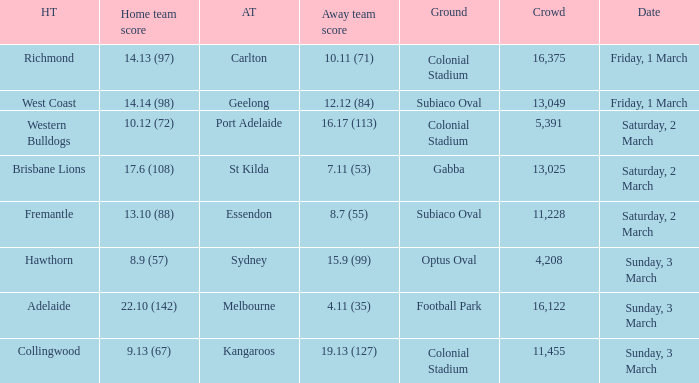What was the home ground for the essendon away team? Subiaco Oval. 